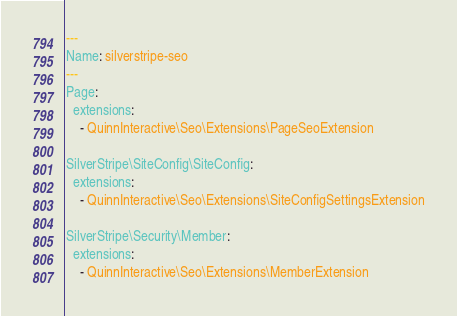<code> <loc_0><loc_0><loc_500><loc_500><_YAML_>---
Name: silverstripe-seo
---
Page:
  extensions:
    - QuinnInteractive\Seo\Extensions\PageSeoExtension

SilverStripe\SiteConfig\SiteConfig:
  extensions:
    - QuinnInteractive\Seo\Extensions\SiteConfigSettingsExtension

SilverStripe\Security\Member:
  extensions:
    - QuinnInteractive\Seo\Extensions\MemberExtension
</code> 